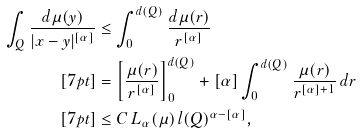Convert formula to latex. <formula><loc_0><loc_0><loc_500><loc_500>\int _ { Q } \frac { d \mu ( y ) } { | x - y | ^ { [ \alpha ] } } & \leq \int _ { 0 } ^ { d ( Q ) } \frac { d \mu ( r ) } { r ^ { [ \alpha ] } } \\ [ 7 p t ] & = \left [ \frac { \mu ( r ) } { r ^ { [ \alpha ] } } \right ] _ { 0 } ^ { d ( Q ) } + [ \alpha ] \int _ { 0 } ^ { d ( Q ) } \frac { \mu ( r ) } { r ^ { [ \alpha ] + 1 } } \, d r \\ [ 7 p t ] & \leq C \, L _ { \alpha } ( \mu ) \, l ( Q ) ^ { \alpha - [ \alpha ] } ,</formula> 